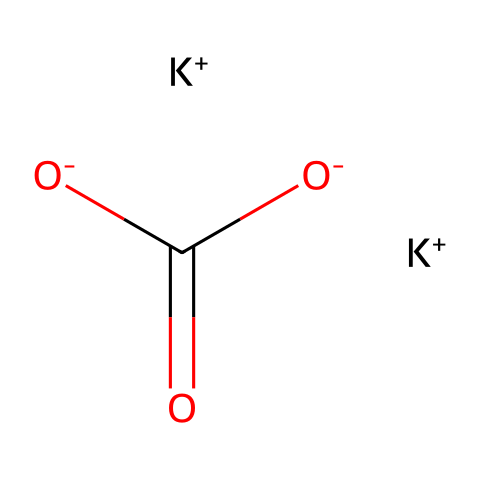What is the molecular formula of this compound? The chemical includes two potassium (K) ions and one carbonate ion (CO3), which gives us the molecular formula K2CO3.
Answer: K2CO3 How many potassium atoms are present in the structure? The SMILES representation contains two instances of K+, indicating there are two potassium atoms in the structure.
Answer: 2 What type of compound is potassium carbonate? Potassium carbonate is classified as a salt, formed from the reaction of a strong base (potassium hydroxide) and a weak acid (carbonic acid).
Answer: salt How many oxygen atoms are there in the carbonate ion? The carbonate ion (CO3) has three oxygen atoms, which can be observed from the composition of the ion itself within the chemical structure.
Answer: 3 What is the charge of the carbonate ion in this structure? The carbonate ion carries a -2 charge, which is represented as [O-]C(=O)[O-] in the SMILES notation.
Answer: -2 What is the primary use of potassium carbonate in local food preservation? Potassium carbonate is primarily used as a food preservative because of its ability to regulate acidity and improve the texture of food.
Answer: preservative 